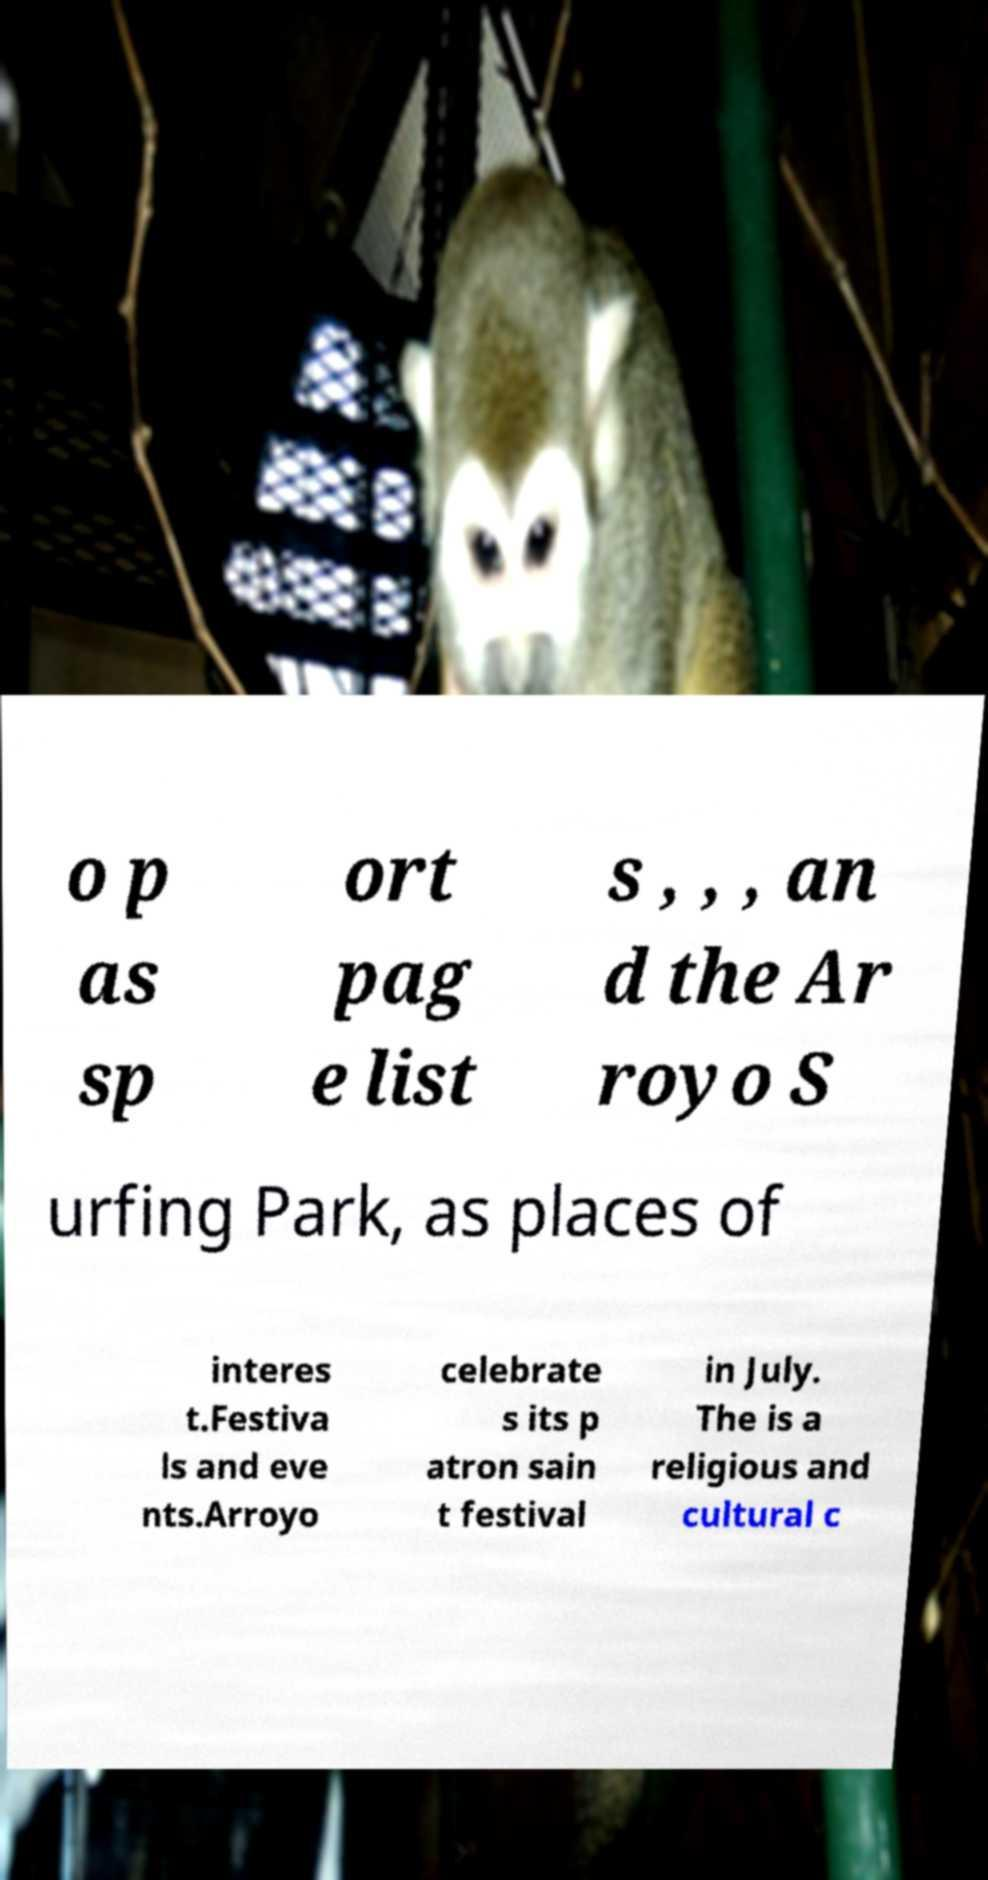Could you assist in decoding the text presented in this image and type it out clearly? o p as sp ort pag e list s , , , an d the Ar royo S urfing Park, as places of interes t.Festiva ls and eve nts.Arroyo celebrate s its p atron sain t festival in July. The is a religious and cultural c 